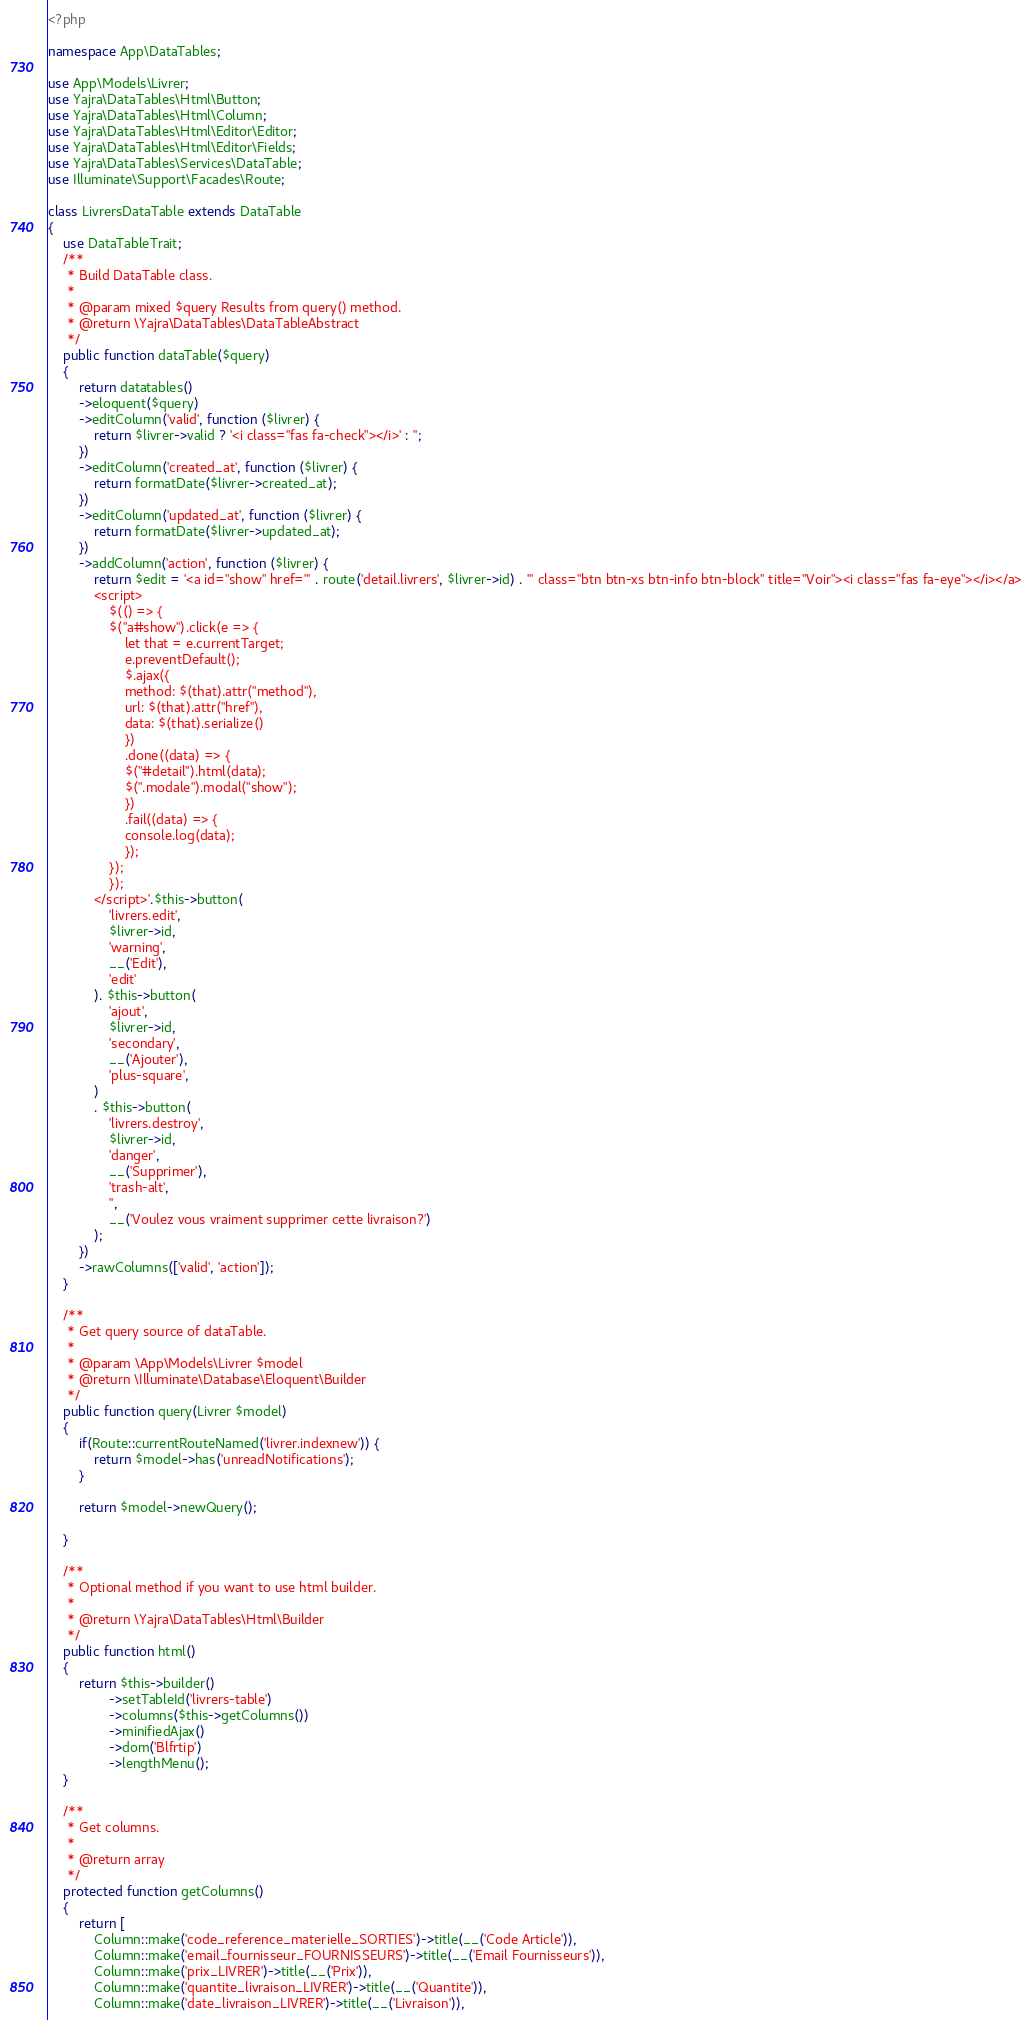Convert code to text. <code><loc_0><loc_0><loc_500><loc_500><_PHP_><?php

namespace App\DataTables;

use App\Models\Livrer;
use Yajra\DataTables\Html\Button;
use Yajra\DataTables\Html\Column;
use Yajra\DataTables\Html\Editor\Editor;
use Yajra\DataTables\Html\Editor\Fields;
use Yajra\DataTables\Services\DataTable;
use Illuminate\Support\Facades\Route;

class LivrersDataTable extends DataTable
{
    use DataTableTrait;
    /**
     * Build DataTable class.
     *
     * @param mixed $query Results from query() method.
     * @return \Yajra\DataTables\DataTableAbstract
     */
    public function dataTable($query)
    {
        return datatables()
        ->eloquent($query)
        ->editColumn('valid', function ($livrer) {
            return $livrer->valid ? '<i class="fas fa-check"></i>' : '';
        })
        ->editColumn('created_at', function ($livrer) {
            return formatDate($livrer->created_at);
        })
        ->editColumn('updated_at', function ($livrer) {
            return formatDate($livrer->updated_at);
        })
        ->addColumn('action', function ($livrer) {
            return $edit = '<a id="show" href="' . route('detail.livrers', $livrer->id) . '" class="btn btn-xs btn-info btn-block" title="Voir"><i class="fas fa-eye"></i></a>
            <script>
                $(() => { 
                $("a#show").click(e => {
                    let that = e.currentTarget;
                    e.preventDefault();
                    $.ajax({
                    method: $(that).attr("method"),
                    url: $(that).attr("href"),
                    data: $(that).serialize()
                    })
                    .done((data) => {
                    $("#detail").html(data);
                    $(".modale").modal("show");
                    })
                    .fail((data) => {
                    console.log(data);
                    });
                });
                });
            </script>'.$this->button(
                'livrers.edit',
                $livrer->id,
                'warning',
                __('Edit'),
                'edit'
            ). $this->button(
                'ajout',
                $livrer->id,
                'secondary',
                __('Ajouter'),
                'plus-square',
            )
            . $this->button(
                'livrers.destroy',
                $livrer->id,
                'danger',
                __('Supprimer'),
                'trash-alt',
                '',
                __('Voulez vous vraiment supprimer cette livraison?')
            );
        })
        ->rawColumns(['valid', 'action']);
    }

    /**
     * Get query source of dataTable.
     *
     * @param \App\Models\Livrer $model
     * @return \Illuminate\Database\Eloquent\Builder
     */
    public function query(Livrer $model)
    {
        if(Route::currentRouteNamed('livrer.indexnew')) {
            return $model->has('unreadNotifications');
        }

        return $model->newQuery();

    }

    /**
     * Optional method if you want to use html builder.
     *
     * @return \Yajra\DataTables\Html\Builder
     */
    public function html()
    {
        return $this->builder()
                ->setTableId('livrers-table')
                ->columns($this->getColumns())
                ->minifiedAjax()
                ->dom('Blfrtip')
                ->lengthMenu();
    }

    /**
     * Get columns.
     *
     * @return array
     */
    protected function getColumns()
    {
        return [
            Column::make('code_reference_materielle_SORTIES')->title(__('Code Article')),
            Column::make('email_fournisseur_FOURNISSEURS')->title(__('Email Fournisseurs')),
            Column::make('prix_LIVRER')->title(__('Prix')),
            Column::make('quantite_livraison_LIVRER')->title(__('Quantite')),
            Column::make('date_livraison_LIVRER')->title(__('Livraison')),</code> 